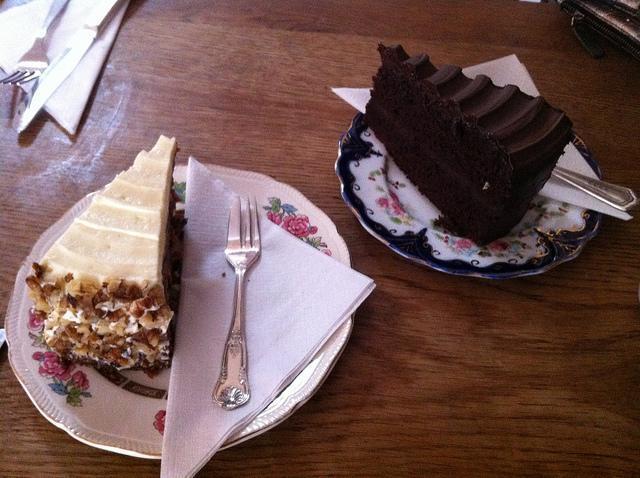How many cakes are there?
Give a very brief answer. 2. 